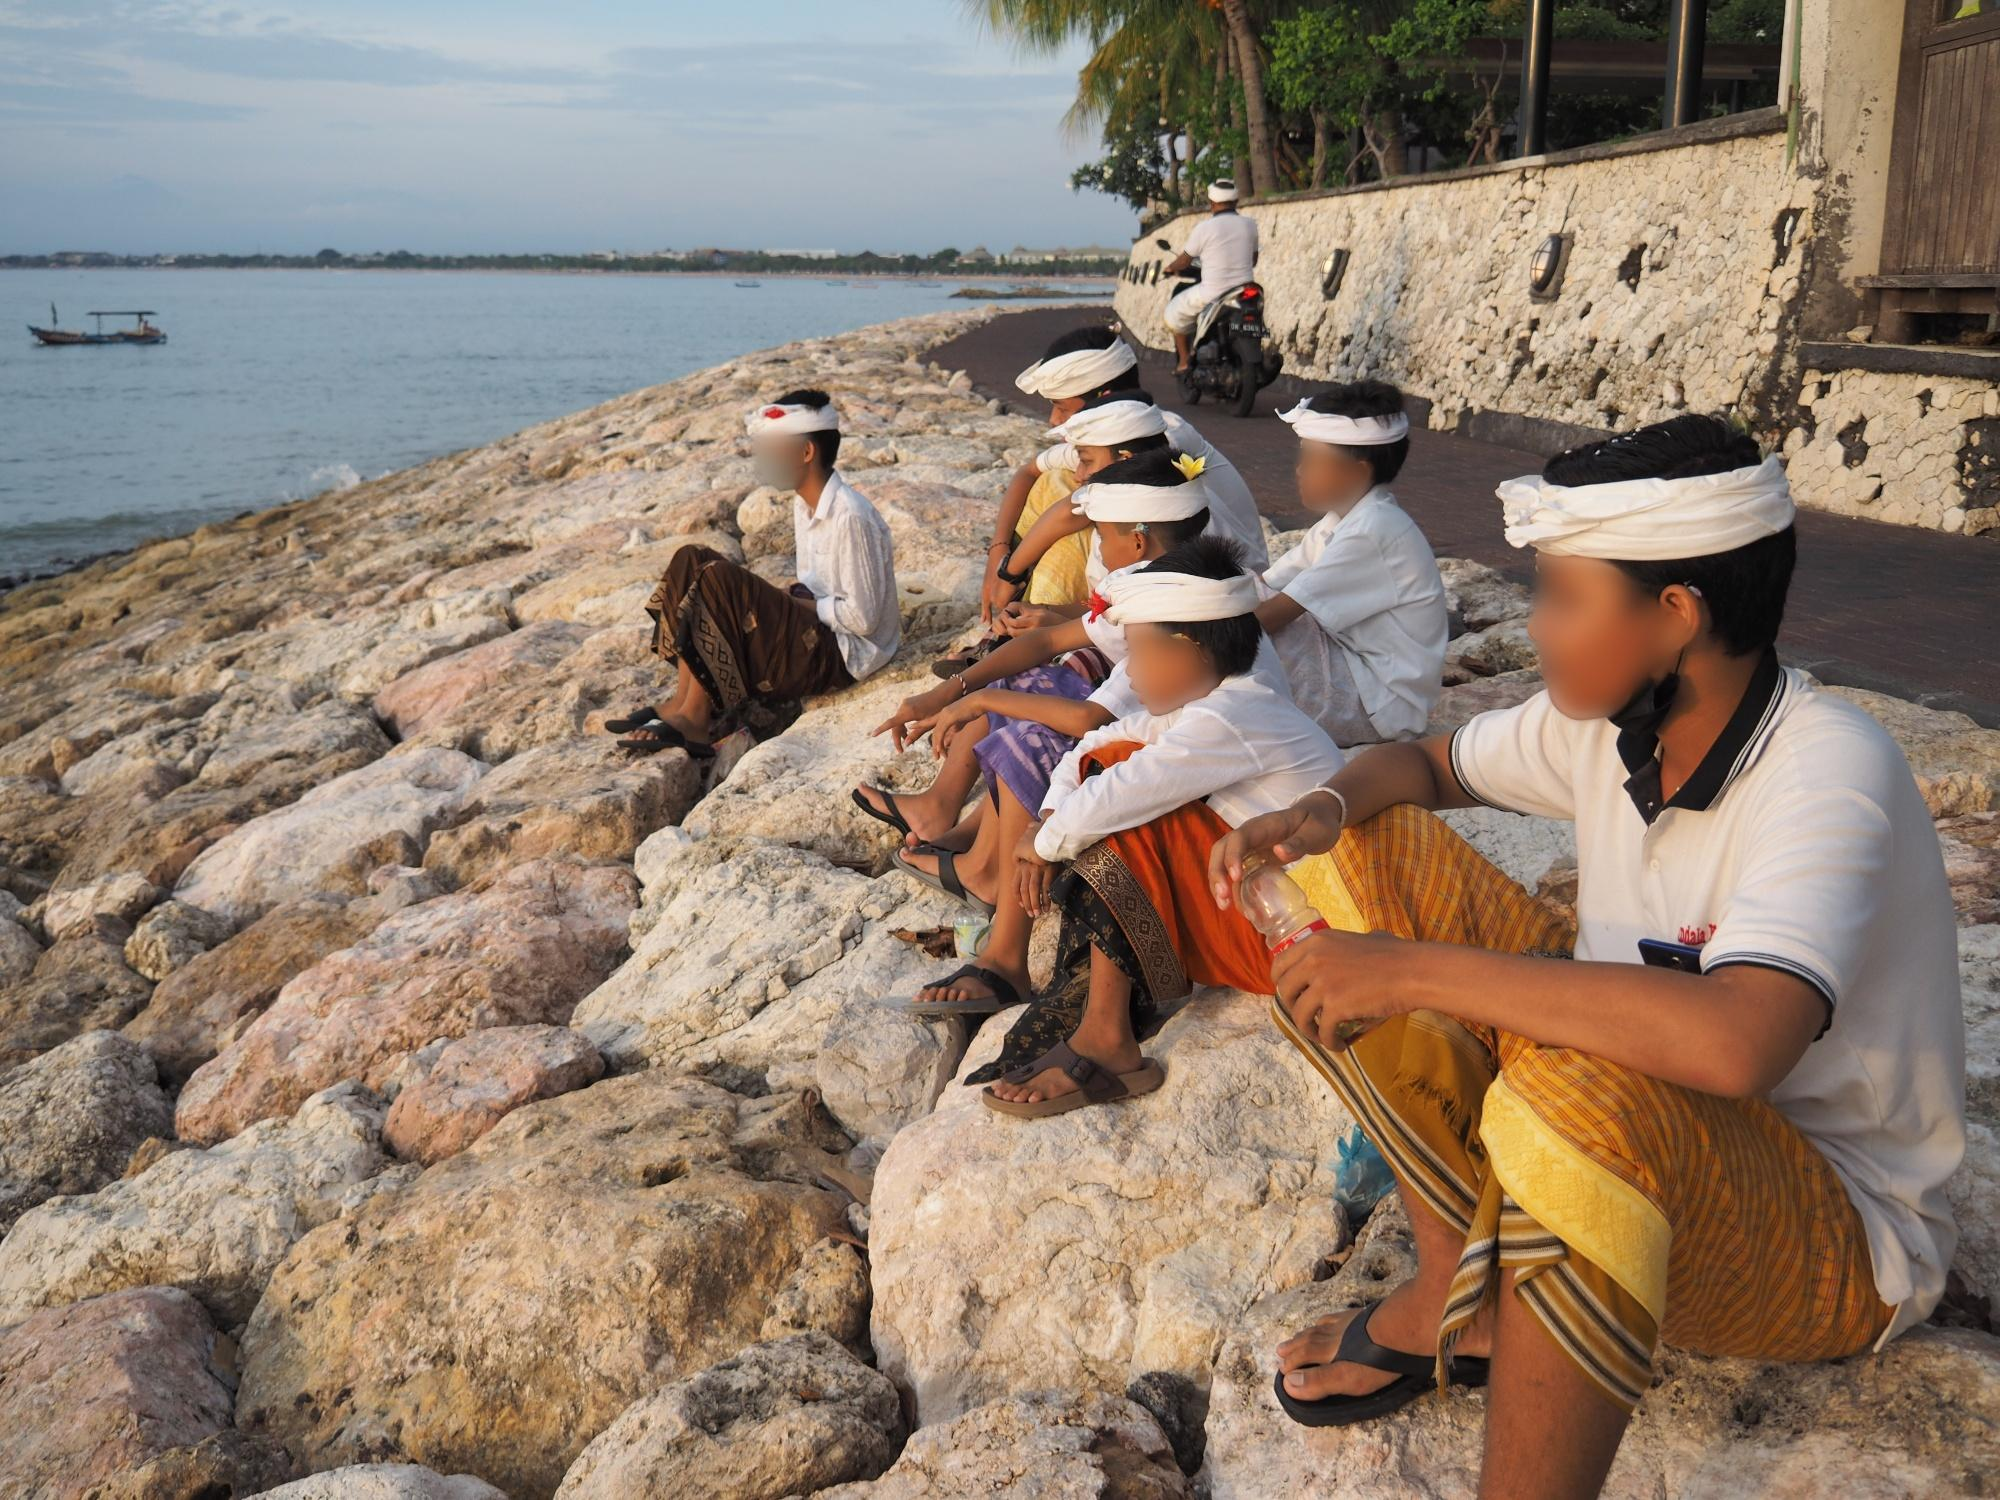What specific cultural importance might the headpiece have in this context? In Balinese culture, the headpiece known as 'udeng' for men and 'subas' for women holds significant cultural importance. These headpieces are typically worn during religious ceremonies, cultural events, and important rituals. They symbolize respect, purity, and readiness for spiritual activities. Wearing a headpiece is also seen as a form of reverence to the deities, showing the wearer's intention to participate in sacred practices harmoniously. In this context, it implies that the individuals are likely involved in a ceremonial or ritualistic activity, underscoring their deep connection to Balinese spiritual traditions. How does the low angle of the photograph affect the perception of the scene? The low angle of the photograph serves to amplify the presence and importance of the individuals and their traditional attire, making them the focal point of the scene. This perspective emphasizes their cultural significance and allows viewers to appreciate the intricate details of their clothing and headpieces. Furthermore, the low angle captures the expanse of the ocean in the background, creating a juxtaposition between the people and the vast natural landscape. This composition adds depth and scale to the image, enhancing the overall sense of serenity and grandeur. Imagine an alternate reality where this scene takes place on another planet. Describe the scenario. In an alternate reality on the azure shores of the planet Oceana, a group of native inhabitants, resembling humans but with iridescent skin that glows in the twilight, are gathered. They wear intricately woven attires made from bioluminescent seaweed and coral fibers, harboring the essence of their vibrant underwater world. Their headpieces are made from crystal-like structures that resonate with the planet's energy fields. They are performing a sacred water ritual to honor the twin moons that govern the tides and the marine life teeming below their rocky perch. The alien ocean, with its phosphorescent waves and floating bioluminescent organisms, creates an ethereal backdrop. As night falls, the water begins to glow in myriad colors, illuminating their serene faces, and painting the scene with otherworldly splendor. 